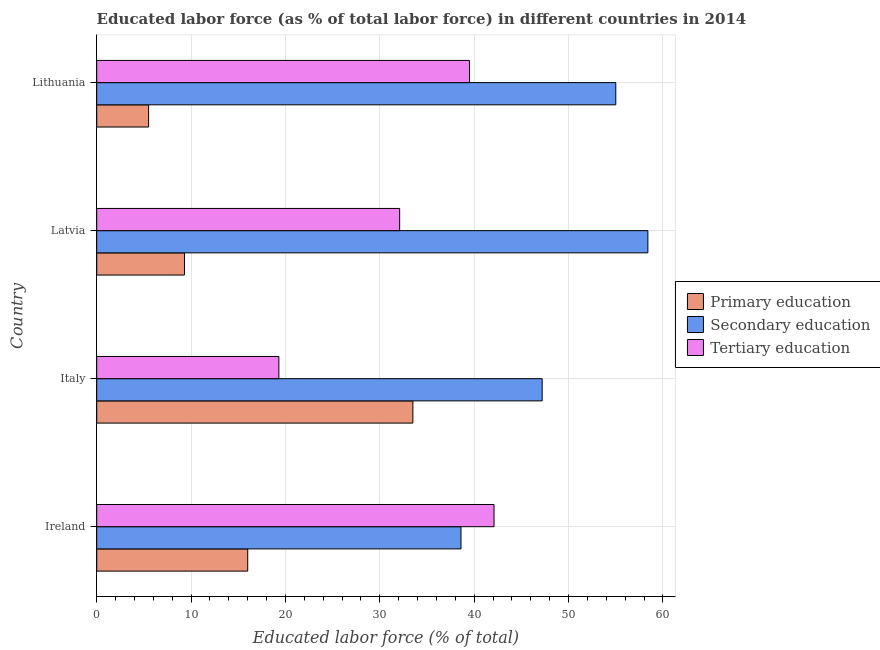What is the label of the 1st group of bars from the top?
Give a very brief answer. Lithuania. In how many cases, is the number of bars for a given country not equal to the number of legend labels?
Ensure brevity in your answer.  0. Across all countries, what is the maximum percentage of labor force who received tertiary education?
Offer a very short reply. 42.1. Across all countries, what is the minimum percentage of labor force who received tertiary education?
Offer a terse response. 19.3. In which country was the percentage of labor force who received secondary education maximum?
Your response must be concise. Latvia. In which country was the percentage of labor force who received secondary education minimum?
Your answer should be very brief. Ireland. What is the total percentage of labor force who received primary education in the graph?
Your response must be concise. 64.3. What is the difference between the percentage of labor force who received tertiary education in Italy and that in Lithuania?
Your response must be concise. -20.2. What is the difference between the percentage of labor force who received tertiary education in Latvia and the percentage of labor force who received primary education in Italy?
Offer a very short reply. -1.4. What is the average percentage of labor force who received secondary education per country?
Your answer should be compact. 49.8. What is the difference between the percentage of labor force who received primary education and percentage of labor force who received secondary education in Lithuania?
Provide a short and direct response. -49.5. In how many countries, is the percentage of labor force who received secondary education greater than 26 %?
Provide a short and direct response. 4. What is the ratio of the percentage of labor force who received primary education in Italy to that in Latvia?
Make the answer very short. 3.6. Is the difference between the percentage of labor force who received secondary education in Ireland and Latvia greater than the difference between the percentage of labor force who received primary education in Ireland and Latvia?
Keep it short and to the point. No. What is the difference between the highest and the second highest percentage of labor force who received secondary education?
Your response must be concise. 3.4. In how many countries, is the percentage of labor force who received secondary education greater than the average percentage of labor force who received secondary education taken over all countries?
Your answer should be very brief. 2. Is the sum of the percentage of labor force who received tertiary education in Italy and Lithuania greater than the maximum percentage of labor force who received secondary education across all countries?
Give a very brief answer. Yes. What does the 1st bar from the top in Ireland represents?
Provide a short and direct response. Tertiary education. What does the 1st bar from the bottom in Ireland represents?
Keep it short and to the point. Primary education. Is it the case that in every country, the sum of the percentage of labor force who received primary education and percentage of labor force who received secondary education is greater than the percentage of labor force who received tertiary education?
Give a very brief answer. Yes. How many bars are there?
Provide a succinct answer. 12. Are all the bars in the graph horizontal?
Your response must be concise. Yes. Does the graph contain grids?
Make the answer very short. Yes. Where does the legend appear in the graph?
Make the answer very short. Center right. How are the legend labels stacked?
Your answer should be very brief. Vertical. What is the title of the graph?
Offer a very short reply. Educated labor force (as % of total labor force) in different countries in 2014. What is the label or title of the X-axis?
Provide a succinct answer. Educated labor force (% of total). What is the Educated labor force (% of total) in Secondary education in Ireland?
Ensure brevity in your answer.  38.6. What is the Educated labor force (% of total) of Tertiary education in Ireland?
Offer a terse response. 42.1. What is the Educated labor force (% of total) in Primary education in Italy?
Ensure brevity in your answer.  33.5. What is the Educated labor force (% of total) in Secondary education in Italy?
Make the answer very short. 47.2. What is the Educated labor force (% of total) in Tertiary education in Italy?
Provide a succinct answer. 19.3. What is the Educated labor force (% of total) of Primary education in Latvia?
Ensure brevity in your answer.  9.3. What is the Educated labor force (% of total) of Secondary education in Latvia?
Offer a terse response. 58.4. What is the Educated labor force (% of total) in Tertiary education in Latvia?
Your answer should be compact. 32.1. What is the Educated labor force (% of total) of Primary education in Lithuania?
Keep it short and to the point. 5.5. What is the Educated labor force (% of total) of Secondary education in Lithuania?
Provide a succinct answer. 55. What is the Educated labor force (% of total) of Tertiary education in Lithuania?
Keep it short and to the point. 39.5. Across all countries, what is the maximum Educated labor force (% of total) of Primary education?
Keep it short and to the point. 33.5. Across all countries, what is the maximum Educated labor force (% of total) in Secondary education?
Your response must be concise. 58.4. Across all countries, what is the maximum Educated labor force (% of total) in Tertiary education?
Ensure brevity in your answer.  42.1. Across all countries, what is the minimum Educated labor force (% of total) in Primary education?
Provide a short and direct response. 5.5. Across all countries, what is the minimum Educated labor force (% of total) of Secondary education?
Provide a short and direct response. 38.6. Across all countries, what is the minimum Educated labor force (% of total) of Tertiary education?
Provide a succinct answer. 19.3. What is the total Educated labor force (% of total) in Primary education in the graph?
Your answer should be very brief. 64.3. What is the total Educated labor force (% of total) of Secondary education in the graph?
Offer a terse response. 199.2. What is the total Educated labor force (% of total) in Tertiary education in the graph?
Give a very brief answer. 133. What is the difference between the Educated labor force (% of total) of Primary education in Ireland and that in Italy?
Keep it short and to the point. -17.5. What is the difference between the Educated labor force (% of total) of Secondary education in Ireland and that in Italy?
Provide a succinct answer. -8.6. What is the difference between the Educated labor force (% of total) of Tertiary education in Ireland and that in Italy?
Offer a very short reply. 22.8. What is the difference between the Educated labor force (% of total) of Primary education in Ireland and that in Latvia?
Make the answer very short. 6.7. What is the difference between the Educated labor force (% of total) of Secondary education in Ireland and that in Latvia?
Give a very brief answer. -19.8. What is the difference between the Educated labor force (% of total) in Tertiary education in Ireland and that in Latvia?
Your response must be concise. 10. What is the difference between the Educated labor force (% of total) of Primary education in Ireland and that in Lithuania?
Make the answer very short. 10.5. What is the difference between the Educated labor force (% of total) of Secondary education in Ireland and that in Lithuania?
Provide a short and direct response. -16.4. What is the difference between the Educated labor force (% of total) of Tertiary education in Ireland and that in Lithuania?
Give a very brief answer. 2.6. What is the difference between the Educated labor force (% of total) in Primary education in Italy and that in Latvia?
Offer a terse response. 24.2. What is the difference between the Educated labor force (% of total) of Secondary education in Italy and that in Latvia?
Give a very brief answer. -11.2. What is the difference between the Educated labor force (% of total) in Tertiary education in Italy and that in Latvia?
Provide a succinct answer. -12.8. What is the difference between the Educated labor force (% of total) in Primary education in Italy and that in Lithuania?
Give a very brief answer. 28. What is the difference between the Educated labor force (% of total) in Secondary education in Italy and that in Lithuania?
Offer a very short reply. -7.8. What is the difference between the Educated labor force (% of total) in Tertiary education in Italy and that in Lithuania?
Offer a terse response. -20.2. What is the difference between the Educated labor force (% of total) of Secondary education in Latvia and that in Lithuania?
Ensure brevity in your answer.  3.4. What is the difference between the Educated labor force (% of total) of Tertiary education in Latvia and that in Lithuania?
Offer a very short reply. -7.4. What is the difference between the Educated labor force (% of total) in Primary education in Ireland and the Educated labor force (% of total) in Secondary education in Italy?
Your response must be concise. -31.2. What is the difference between the Educated labor force (% of total) in Primary education in Ireland and the Educated labor force (% of total) in Tertiary education in Italy?
Your answer should be compact. -3.3. What is the difference between the Educated labor force (% of total) of Secondary education in Ireland and the Educated labor force (% of total) of Tertiary education in Italy?
Offer a very short reply. 19.3. What is the difference between the Educated labor force (% of total) in Primary education in Ireland and the Educated labor force (% of total) in Secondary education in Latvia?
Your response must be concise. -42.4. What is the difference between the Educated labor force (% of total) of Primary education in Ireland and the Educated labor force (% of total) of Tertiary education in Latvia?
Provide a succinct answer. -16.1. What is the difference between the Educated labor force (% of total) of Secondary education in Ireland and the Educated labor force (% of total) of Tertiary education in Latvia?
Make the answer very short. 6.5. What is the difference between the Educated labor force (% of total) in Primary education in Ireland and the Educated labor force (% of total) in Secondary education in Lithuania?
Provide a succinct answer. -39. What is the difference between the Educated labor force (% of total) of Primary education in Ireland and the Educated labor force (% of total) of Tertiary education in Lithuania?
Make the answer very short. -23.5. What is the difference between the Educated labor force (% of total) in Secondary education in Ireland and the Educated labor force (% of total) in Tertiary education in Lithuania?
Provide a succinct answer. -0.9. What is the difference between the Educated labor force (% of total) in Primary education in Italy and the Educated labor force (% of total) in Secondary education in Latvia?
Offer a terse response. -24.9. What is the difference between the Educated labor force (% of total) in Primary education in Italy and the Educated labor force (% of total) in Tertiary education in Latvia?
Provide a succinct answer. 1.4. What is the difference between the Educated labor force (% of total) in Primary education in Italy and the Educated labor force (% of total) in Secondary education in Lithuania?
Ensure brevity in your answer.  -21.5. What is the difference between the Educated labor force (% of total) of Primary education in Italy and the Educated labor force (% of total) of Tertiary education in Lithuania?
Keep it short and to the point. -6. What is the difference between the Educated labor force (% of total) in Secondary education in Italy and the Educated labor force (% of total) in Tertiary education in Lithuania?
Make the answer very short. 7.7. What is the difference between the Educated labor force (% of total) in Primary education in Latvia and the Educated labor force (% of total) in Secondary education in Lithuania?
Ensure brevity in your answer.  -45.7. What is the difference between the Educated labor force (% of total) in Primary education in Latvia and the Educated labor force (% of total) in Tertiary education in Lithuania?
Provide a short and direct response. -30.2. What is the difference between the Educated labor force (% of total) in Secondary education in Latvia and the Educated labor force (% of total) in Tertiary education in Lithuania?
Keep it short and to the point. 18.9. What is the average Educated labor force (% of total) of Primary education per country?
Offer a very short reply. 16.07. What is the average Educated labor force (% of total) in Secondary education per country?
Offer a very short reply. 49.8. What is the average Educated labor force (% of total) in Tertiary education per country?
Provide a short and direct response. 33.25. What is the difference between the Educated labor force (% of total) of Primary education and Educated labor force (% of total) of Secondary education in Ireland?
Your response must be concise. -22.6. What is the difference between the Educated labor force (% of total) in Primary education and Educated labor force (% of total) in Tertiary education in Ireland?
Offer a terse response. -26.1. What is the difference between the Educated labor force (% of total) in Secondary education and Educated labor force (% of total) in Tertiary education in Ireland?
Keep it short and to the point. -3.5. What is the difference between the Educated labor force (% of total) in Primary education and Educated labor force (% of total) in Secondary education in Italy?
Offer a very short reply. -13.7. What is the difference between the Educated labor force (% of total) in Secondary education and Educated labor force (% of total) in Tertiary education in Italy?
Ensure brevity in your answer.  27.9. What is the difference between the Educated labor force (% of total) of Primary education and Educated labor force (% of total) of Secondary education in Latvia?
Keep it short and to the point. -49.1. What is the difference between the Educated labor force (% of total) of Primary education and Educated labor force (% of total) of Tertiary education in Latvia?
Give a very brief answer. -22.8. What is the difference between the Educated labor force (% of total) in Secondary education and Educated labor force (% of total) in Tertiary education in Latvia?
Offer a very short reply. 26.3. What is the difference between the Educated labor force (% of total) in Primary education and Educated labor force (% of total) in Secondary education in Lithuania?
Ensure brevity in your answer.  -49.5. What is the difference between the Educated labor force (% of total) of Primary education and Educated labor force (% of total) of Tertiary education in Lithuania?
Keep it short and to the point. -34. What is the difference between the Educated labor force (% of total) of Secondary education and Educated labor force (% of total) of Tertiary education in Lithuania?
Your answer should be compact. 15.5. What is the ratio of the Educated labor force (% of total) of Primary education in Ireland to that in Italy?
Make the answer very short. 0.48. What is the ratio of the Educated labor force (% of total) in Secondary education in Ireland to that in Italy?
Offer a terse response. 0.82. What is the ratio of the Educated labor force (% of total) in Tertiary education in Ireland to that in Italy?
Keep it short and to the point. 2.18. What is the ratio of the Educated labor force (% of total) of Primary education in Ireland to that in Latvia?
Your answer should be compact. 1.72. What is the ratio of the Educated labor force (% of total) in Secondary education in Ireland to that in Latvia?
Your answer should be compact. 0.66. What is the ratio of the Educated labor force (% of total) of Tertiary education in Ireland to that in Latvia?
Make the answer very short. 1.31. What is the ratio of the Educated labor force (% of total) of Primary education in Ireland to that in Lithuania?
Offer a terse response. 2.91. What is the ratio of the Educated labor force (% of total) in Secondary education in Ireland to that in Lithuania?
Give a very brief answer. 0.7. What is the ratio of the Educated labor force (% of total) in Tertiary education in Ireland to that in Lithuania?
Offer a terse response. 1.07. What is the ratio of the Educated labor force (% of total) of Primary education in Italy to that in Latvia?
Provide a succinct answer. 3.6. What is the ratio of the Educated labor force (% of total) of Secondary education in Italy to that in Latvia?
Offer a terse response. 0.81. What is the ratio of the Educated labor force (% of total) in Tertiary education in Italy to that in Latvia?
Keep it short and to the point. 0.6. What is the ratio of the Educated labor force (% of total) in Primary education in Italy to that in Lithuania?
Your answer should be compact. 6.09. What is the ratio of the Educated labor force (% of total) of Secondary education in Italy to that in Lithuania?
Your response must be concise. 0.86. What is the ratio of the Educated labor force (% of total) of Tertiary education in Italy to that in Lithuania?
Provide a short and direct response. 0.49. What is the ratio of the Educated labor force (% of total) in Primary education in Latvia to that in Lithuania?
Give a very brief answer. 1.69. What is the ratio of the Educated labor force (% of total) in Secondary education in Latvia to that in Lithuania?
Keep it short and to the point. 1.06. What is the ratio of the Educated labor force (% of total) in Tertiary education in Latvia to that in Lithuania?
Give a very brief answer. 0.81. What is the difference between the highest and the second highest Educated labor force (% of total) in Primary education?
Your response must be concise. 17.5. What is the difference between the highest and the second highest Educated labor force (% of total) in Secondary education?
Make the answer very short. 3.4. What is the difference between the highest and the lowest Educated labor force (% of total) in Secondary education?
Your answer should be very brief. 19.8. What is the difference between the highest and the lowest Educated labor force (% of total) of Tertiary education?
Offer a terse response. 22.8. 